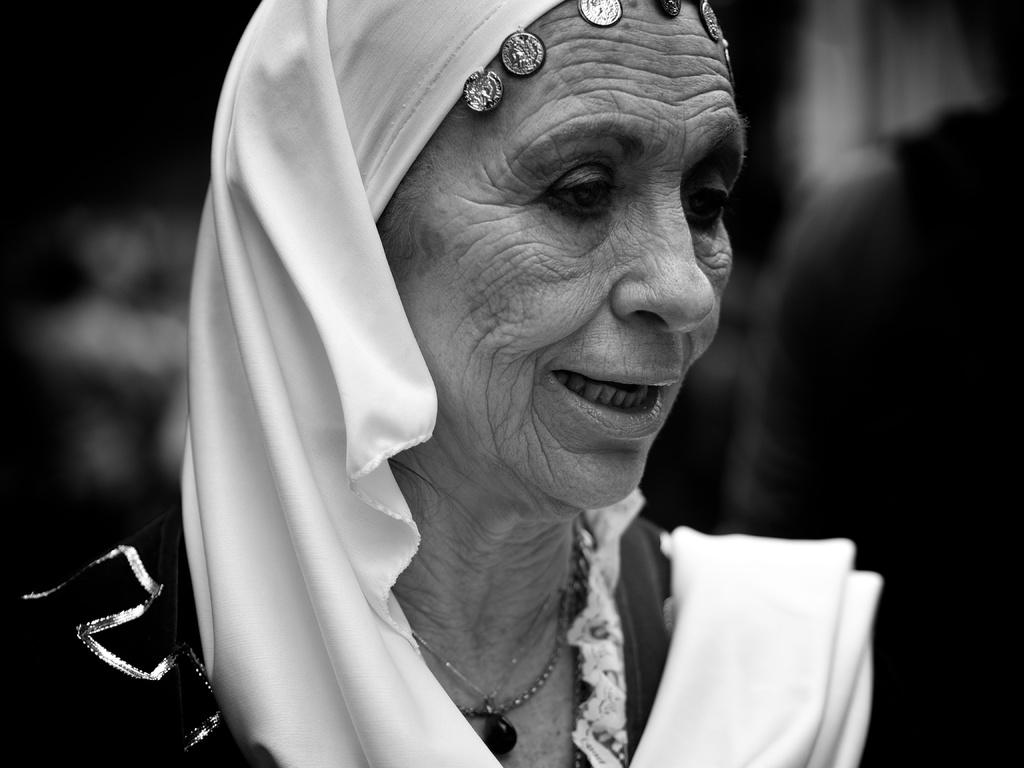Who is the main subject in the image? There is a lady in the image. What can be observed about the background of the image? The background of the image is blurred. How is the image presented in terms of color? The image is in black and white mode. What design is visible on the calculator in the image? There is no calculator present in the image. How does the lady push the object in the image? There is no object being pushed in the image; the lady is not performing any action. 